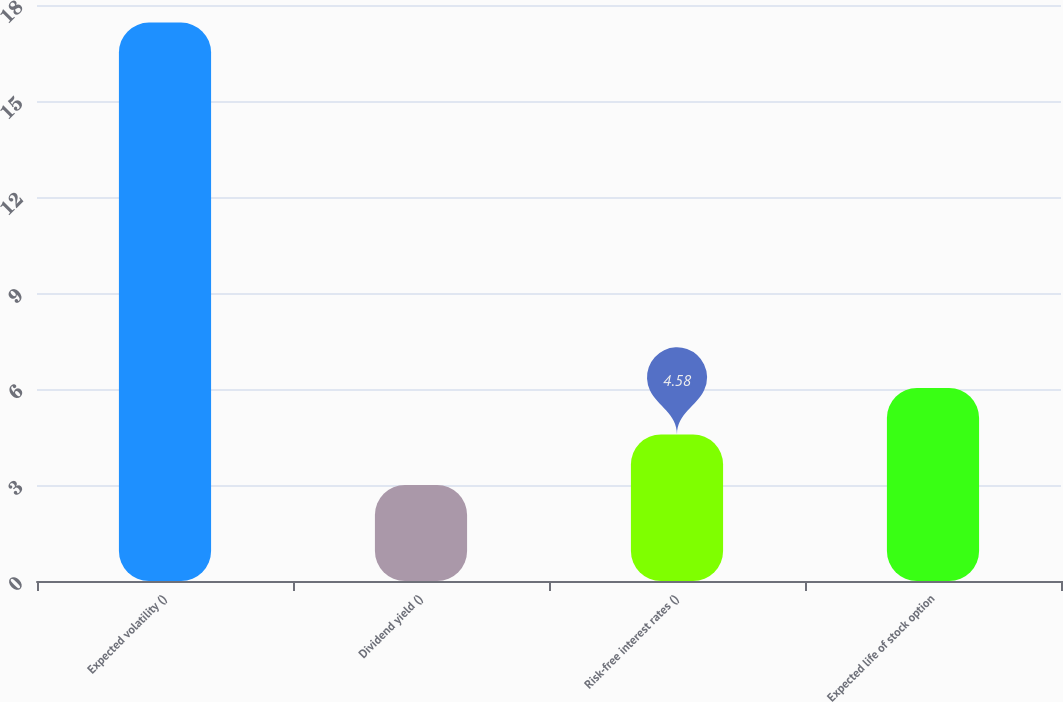Convert chart to OTSL. <chart><loc_0><loc_0><loc_500><loc_500><bar_chart><fcel>Expected volatility ()<fcel>Dividend yield ()<fcel>Risk-free interest rates ()<fcel>Expected life of stock option<nl><fcel>17.45<fcel>3<fcel>4.58<fcel>6.03<nl></chart> 